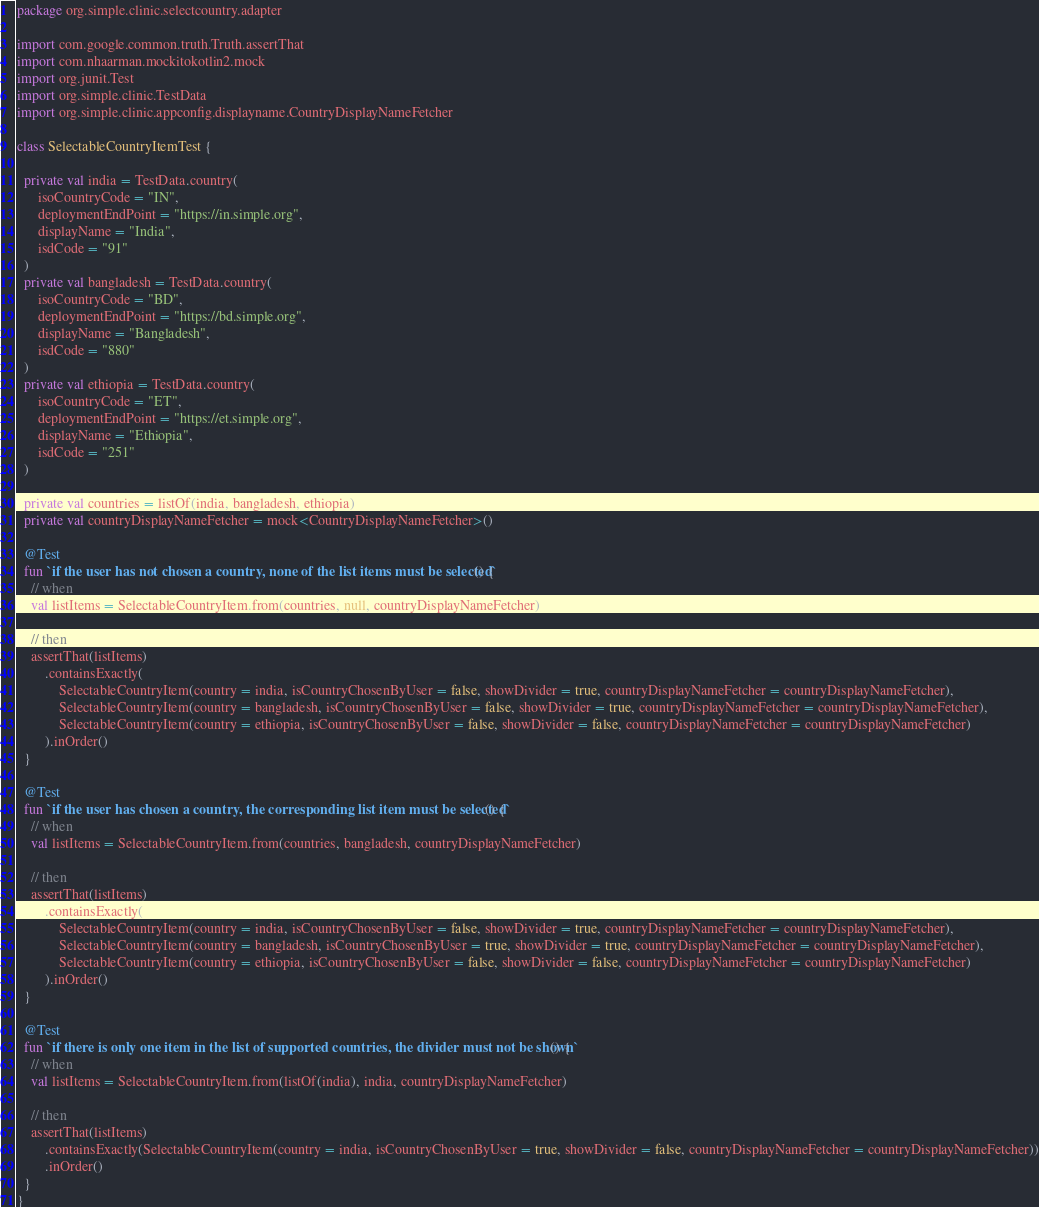<code> <loc_0><loc_0><loc_500><loc_500><_Kotlin_>package org.simple.clinic.selectcountry.adapter

import com.google.common.truth.Truth.assertThat
import com.nhaarman.mockitokotlin2.mock
import org.junit.Test
import org.simple.clinic.TestData
import org.simple.clinic.appconfig.displayname.CountryDisplayNameFetcher

class SelectableCountryItemTest {

  private val india = TestData.country(
      isoCountryCode = "IN",
      deploymentEndPoint = "https://in.simple.org",
      displayName = "India",
      isdCode = "91"
  )
  private val bangladesh = TestData.country(
      isoCountryCode = "BD",
      deploymentEndPoint = "https://bd.simple.org",
      displayName = "Bangladesh",
      isdCode = "880"
  )
  private val ethiopia = TestData.country(
      isoCountryCode = "ET",
      deploymentEndPoint = "https://et.simple.org",
      displayName = "Ethiopia",
      isdCode = "251"
  )

  private val countries = listOf(india, bangladesh, ethiopia)
  private val countryDisplayNameFetcher = mock<CountryDisplayNameFetcher>()

  @Test
  fun `if the user has not chosen a country, none of the list items must be selected`() {
    // when
    val listItems = SelectableCountryItem.from(countries, null, countryDisplayNameFetcher)

    // then
    assertThat(listItems)
        .containsExactly(
            SelectableCountryItem(country = india, isCountryChosenByUser = false, showDivider = true, countryDisplayNameFetcher = countryDisplayNameFetcher),
            SelectableCountryItem(country = bangladesh, isCountryChosenByUser = false, showDivider = true, countryDisplayNameFetcher = countryDisplayNameFetcher),
            SelectableCountryItem(country = ethiopia, isCountryChosenByUser = false, showDivider = false, countryDisplayNameFetcher = countryDisplayNameFetcher)
        ).inOrder()
  }

  @Test
  fun `if the user has chosen a country, the corresponding list item must be selected`() {
    // when
    val listItems = SelectableCountryItem.from(countries, bangladesh, countryDisplayNameFetcher)

    // then
    assertThat(listItems)
        .containsExactly(
            SelectableCountryItem(country = india, isCountryChosenByUser = false, showDivider = true, countryDisplayNameFetcher = countryDisplayNameFetcher),
            SelectableCountryItem(country = bangladesh, isCountryChosenByUser = true, showDivider = true, countryDisplayNameFetcher = countryDisplayNameFetcher),
            SelectableCountryItem(country = ethiopia, isCountryChosenByUser = false, showDivider = false, countryDisplayNameFetcher = countryDisplayNameFetcher)
        ).inOrder()
  }

  @Test
  fun `if there is only one item in the list of supported countries, the divider must not be shown`() {
    // when
    val listItems = SelectableCountryItem.from(listOf(india), india, countryDisplayNameFetcher)

    // then
    assertThat(listItems)
        .containsExactly(SelectableCountryItem(country = india, isCountryChosenByUser = true, showDivider = false, countryDisplayNameFetcher = countryDisplayNameFetcher))
        .inOrder()
  }
}
</code> 